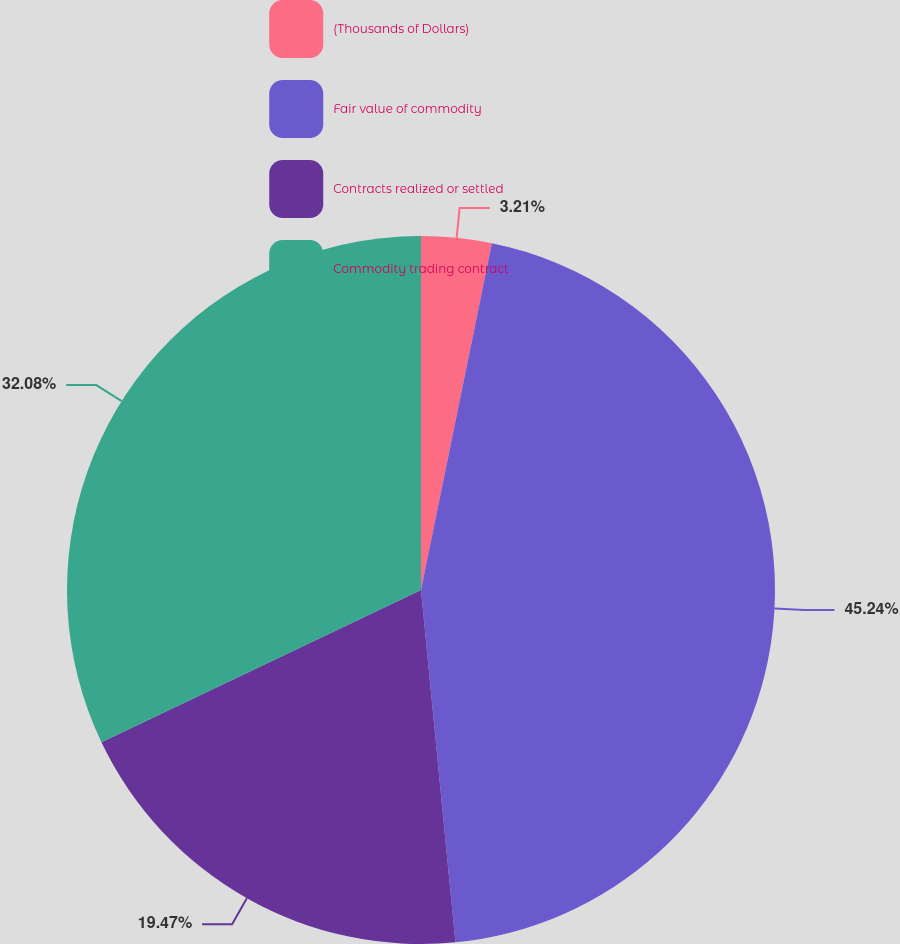Convert chart. <chart><loc_0><loc_0><loc_500><loc_500><pie_chart><fcel>(Thousands of Dollars)<fcel>Fair value of commodity<fcel>Contracts realized or settled<fcel>Commodity trading contract<nl><fcel>3.21%<fcel>45.24%<fcel>19.47%<fcel>32.08%<nl></chart> 